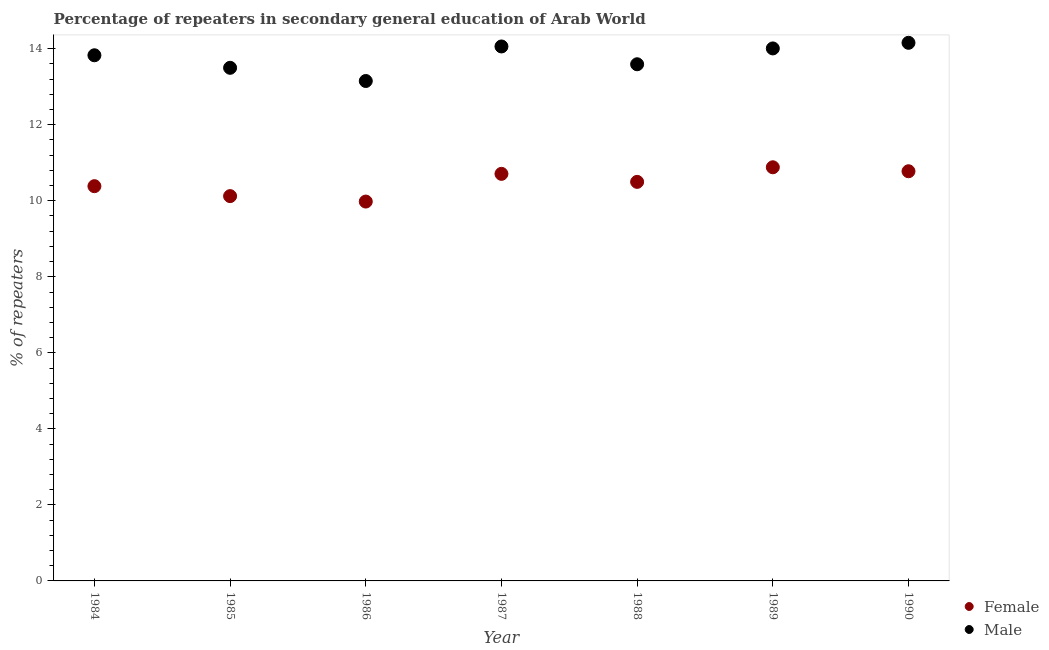How many different coloured dotlines are there?
Provide a succinct answer. 2. Is the number of dotlines equal to the number of legend labels?
Your response must be concise. Yes. What is the percentage of male repeaters in 1986?
Provide a succinct answer. 13.15. Across all years, what is the maximum percentage of female repeaters?
Offer a very short reply. 10.88. Across all years, what is the minimum percentage of female repeaters?
Ensure brevity in your answer.  9.98. In which year was the percentage of male repeaters maximum?
Provide a short and direct response. 1990. What is the total percentage of female repeaters in the graph?
Provide a short and direct response. 73.35. What is the difference between the percentage of male repeaters in 1984 and that in 1990?
Make the answer very short. -0.33. What is the difference between the percentage of male repeaters in 1987 and the percentage of female repeaters in 1988?
Provide a short and direct response. 3.56. What is the average percentage of female repeaters per year?
Provide a succinct answer. 10.48. In the year 1986, what is the difference between the percentage of male repeaters and percentage of female repeaters?
Ensure brevity in your answer.  3.17. In how many years, is the percentage of male repeaters greater than 4 %?
Provide a succinct answer. 7. What is the ratio of the percentage of male repeaters in 1985 to that in 1988?
Provide a short and direct response. 0.99. What is the difference between the highest and the second highest percentage of male repeaters?
Your response must be concise. 0.1. What is the difference between the highest and the lowest percentage of male repeaters?
Offer a terse response. 1. In how many years, is the percentage of female repeaters greater than the average percentage of female repeaters taken over all years?
Provide a succinct answer. 4. Does the percentage of female repeaters monotonically increase over the years?
Provide a short and direct response. No. How many dotlines are there?
Provide a short and direct response. 2. Are the values on the major ticks of Y-axis written in scientific E-notation?
Ensure brevity in your answer.  No. Does the graph contain grids?
Ensure brevity in your answer.  No. Where does the legend appear in the graph?
Your answer should be very brief. Bottom right. How are the legend labels stacked?
Provide a short and direct response. Vertical. What is the title of the graph?
Your answer should be compact. Percentage of repeaters in secondary general education of Arab World. What is the label or title of the Y-axis?
Your answer should be very brief. % of repeaters. What is the % of repeaters in Female in 1984?
Your answer should be very brief. 10.38. What is the % of repeaters of Male in 1984?
Provide a succinct answer. 13.83. What is the % of repeaters of Female in 1985?
Your response must be concise. 10.12. What is the % of repeaters in Male in 1985?
Keep it short and to the point. 13.5. What is the % of repeaters in Female in 1986?
Give a very brief answer. 9.98. What is the % of repeaters in Male in 1986?
Provide a succinct answer. 13.15. What is the % of repeaters of Female in 1987?
Ensure brevity in your answer.  10.71. What is the % of repeaters in Male in 1987?
Your answer should be very brief. 14.06. What is the % of repeaters of Female in 1988?
Provide a short and direct response. 10.5. What is the % of repeaters in Male in 1988?
Provide a succinct answer. 13.59. What is the % of repeaters of Female in 1989?
Your answer should be very brief. 10.88. What is the % of repeaters in Male in 1989?
Your response must be concise. 14.01. What is the % of repeaters in Female in 1990?
Keep it short and to the point. 10.78. What is the % of repeaters in Male in 1990?
Your response must be concise. 14.16. Across all years, what is the maximum % of repeaters of Female?
Your answer should be very brief. 10.88. Across all years, what is the maximum % of repeaters of Male?
Offer a terse response. 14.16. Across all years, what is the minimum % of repeaters of Female?
Your answer should be compact. 9.98. Across all years, what is the minimum % of repeaters in Male?
Provide a succinct answer. 13.15. What is the total % of repeaters in Female in the graph?
Ensure brevity in your answer.  73.35. What is the total % of repeaters of Male in the graph?
Make the answer very short. 96.29. What is the difference between the % of repeaters in Female in 1984 and that in 1985?
Provide a succinct answer. 0.26. What is the difference between the % of repeaters of Male in 1984 and that in 1985?
Keep it short and to the point. 0.33. What is the difference between the % of repeaters in Female in 1984 and that in 1986?
Keep it short and to the point. 0.4. What is the difference between the % of repeaters in Male in 1984 and that in 1986?
Offer a very short reply. 0.68. What is the difference between the % of repeaters of Female in 1984 and that in 1987?
Provide a short and direct response. -0.32. What is the difference between the % of repeaters in Male in 1984 and that in 1987?
Keep it short and to the point. -0.23. What is the difference between the % of repeaters in Female in 1984 and that in 1988?
Offer a terse response. -0.11. What is the difference between the % of repeaters in Male in 1984 and that in 1988?
Make the answer very short. 0.24. What is the difference between the % of repeaters of Female in 1984 and that in 1989?
Your answer should be very brief. -0.5. What is the difference between the % of repeaters in Male in 1984 and that in 1989?
Make the answer very short. -0.18. What is the difference between the % of repeaters of Female in 1984 and that in 1990?
Offer a very short reply. -0.39. What is the difference between the % of repeaters of Male in 1984 and that in 1990?
Offer a very short reply. -0.33. What is the difference between the % of repeaters of Female in 1985 and that in 1986?
Provide a short and direct response. 0.14. What is the difference between the % of repeaters of Male in 1985 and that in 1986?
Provide a succinct answer. 0.35. What is the difference between the % of repeaters in Female in 1985 and that in 1987?
Your answer should be compact. -0.59. What is the difference between the % of repeaters of Male in 1985 and that in 1987?
Provide a short and direct response. -0.56. What is the difference between the % of repeaters of Female in 1985 and that in 1988?
Give a very brief answer. -0.37. What is the difference between the % of repeaters in Male in 1985 and that in 1988?
Ensure brevity in your answer.  -0.09. What is the difference between the % of repeaters in Female in 1985 and that in 1989?
Your answer should be very brief. -0.76. What is the difference between the % of repeaters of Male in 1985 and that in 1989?
Provide a succinct answer. -0.51. What is the difference between the % of repeaters of Female in 1985 and that in 1990?
Give a very brief answer. -0.65. What is the difference between the % of repeaters in Male in 1985 and that in 1990?
Give a very brief answer. -0.66. What is the difference between the % of repeaters in Female in 1986 and that in 1987?
Your answer should be compact. -0.73. What is the difference between the % of repeaters of Male in 1986 and that in 1987?
Give a very brief answer. -0.91. What is the difference between the % of repeaters in Female in 1986 and that in 1988?
Provide a short and direct response. -0.52. What is the difference between the % of repeaters in Male in 1986 and that in 1988?
Provide a short and direct response. -0.44. What is the difference between the % of repeaters in Female in 1986 and that in 1989?
Your answer should be very brief. -0.9. What is the difference between the % of repeaters in Male in 1986 and that in 1989?
Offer a terse response. -0.86. What is the difference between the % of repeaters of Female in 1986 and that in 1990?
Provide a succinct answer. -0.8. What is the difference between the % of repeaters of Male in 1986 and that in 1990?
Keep it short and to the point. -1. What is the difference between the % of repeaters of Female in 1987 and that in 1988?
Keep it short and to the point. 0.21. What is the difference between the % of repeaters of Male in 1987 and that in 1988?
Keep it short and to the point. 0.47. What is the difference between the % of repeaters in Female in 1987 and that in 1989?
Offer a terse response. -0.17. What is the difference between the % of repeaters in Male in 1987 and that in 1989?
Provide a succinct answer. 0.05. What is the difference between the % of repeaters in Female in 1987 and that in 1990?
Make the answer very short. -0.07. What is the difference between the % of repeaters in Male in 1987 and that in 1990?
Provide a short and direct response. -0.1. What is the difference between the % of repeaters of Female in 1988 and that in 1989?
Make the answer very short. -0.38. What is the difference between the % of repeaters of Male in 1988 and that in 1989?
Keep it short and to the point. -0.42. What is the difference between the % of repeaters of Female in 1988 and that in 1990?
Give a very brief answer. -0.28. What is the difference between the % of repeaters in Male in 1988 and that in 1990?
Your response must be concise. -0.56. What is the difference between the % of repeaters in Female in 1989 and that in 1990?
Your answer should be compact. 0.1. What is the difference between the % of repeaters in Male in 1989 and that in 1990?
Give a very brief answer. -0.15. What is the difference between the % of repeaters of Female in 1984 and the % of repeaters of Male in 1985?
Your response must be concise. -3.11. What is the difference between the % of repeaters of Female in 1984 and the % of repeaters of Male in 1986?
Your answer should be very brief. -2.77. What is the difference between the % of repeaters in Female in 1984 and the % of repeaters in Male in 1987?
Offer a terse response. -3.68. What is the difference between the % of repeaters in Female in 1984 and the % of repeaters in Male in 1988?
Give a very brief answer. -3.21. What is the difference between the % of repeaters of Female in 1984 and the % of repeaters of Male in 1989?
Offer a terse response. -3.62. What is the difference between the % of repeaters in Female in 1984 and the % of repeaters in Male in 1990?
Ensure brevity in your answer.  -3.77. What is the difference between the % of repeaters in Female in 1985 and the % of repeaters in Male in 1986?
Provide a succinct answer. -3.03. What is the difference between the % of repeaters of Female in 1985 and the % of repeaters of Male in 1987?
Offer a very short reply. -3.94. What is the difference between the % of repeaters in Female in 1985 and the % of repeaters in Male in 1988?
Offer a very short reply. -3.47. What is the difference between the % of repeaters in Female in 1985 and the % of repeaters in Male in 1989?
Offer a very short reply. -3.89. What is the difference between the % of repeaters in Female in 1985 and the % of repeaters in Male in 1990?
Make the answer very short. -4.03. What is the difference between the % of repeaters of Female in 1986 and the % of repeaters of Male in 1987?
Provide a short and direct response. -4.08. What is the difference between the % of repeaters in Female in 1986 and the % of repeaters in Male in 1988?
Ensure brevity in your answer.  -3.61. What is the difference between the % of repeaters in Female in 1986 and the % of repeaters in Male in 1989?
Your response must be concise. -4.03. What is the difference between the % of repeaters in Female in 1986 and the % of repeaters in Male in 1990?
Your answer should be very brief. -4.18. What is the difference between the % of repeaters of Female in 1987 and the % of repeaters of Male in 1988?
Your answer should be compact. -2.88. What is the difference between the % of repeaters in Female in 1987 and the % of repeaters in Male in 1989?
Give a very brief answer. -3.3. What is the difference between the % of repeaters of Female in 1987 and the % of repeaters of Male in 1990?
Keep it short and to the point. -3.45. What is the difference between the % of repeaters of Female in 1988 and the % of repeaters of Male in 1989?
Ensure brevity in your answer.  -3.51. What is the difference between the % of repeaters of Female in 1988 and the % of repeaters of Male in 1990?
Offer a very short reply. -3.66. What is the difference between the % of repeaters of Female in 1989 and the % of repeaters of Male in 1990?
Make the answer very short. -3.27. What is the average % of repeaters of Female per year?
Provide a succinct answer. 10.48. What is the average % of repeaters of Male per year?
Offer a very short reply. 13.76. In the year 1984, what is the difference between the % of repeaters in Female and % of repeaters in Male?
Give a very brief answer. -3.44. In the year 1985, what is the difference between the % of repeaters of Female and % of repeaters of Male?
Give a very brief answer. -3.38. In the year 1986, what is the difference between the % of repeaters of Female and % of repeaters of Male?
Your response must be concise. -3.17. In the year 1987, what is the difference between the % of repeaters in Female and % of repeaters in Male?
Ensure brevity in your answer.  -3.35. In the year 1988, what is the difference between the % of repeaters in Female and % of repeaters in Male?
Your response must be concise. -3.09. In the year 1989, what is the difference between the % of repeaters of Female and % of repeaters of Male?
Offer a very short reply. -3.13. In the year 1990, what is the difference between the % of repeaters of Female and % of repeaters of Male?
Your response must be concise. -3.38. What is the ratio of the % of repeaters in Female in 1984 to that in 1985?
Offer a terse response. 1.03. What is the ratio of the % of repeaters of Male in 1984 to that in 1985?
Offer a terse response. 1.02. What is the ratio of the % of repeaters of Female in 1984 to that in 1986?
Provide a succinct answer. 1.04. What is the ratio of the % of repeaters in Male in 1984 to that in 1986?
Ensure brevity in your answer.  1.05. What is the ratio of the % of repeaters of Female in 1984 to that in 1987?
Your response must be concise. 0.97. What is the ratio of the % of repeaters of Male in 1984 to that in 1987?
Provide a succinct answer. 0.98. What is the ratio of the % of repeaters of Female in 1984 to that in 1988?
Make the answer very short. 0.99. What is the ratio of the % of repeaters of Male in 1984 to that in 1988?
Make the answer very short. 1.02. What is the ratio of the % of repeaters in Female in 1984 to that in 1989?
Ensure brevity in your answer.  0.95. What is the ratio of the % of repeaters of Male in 1984 to that in 1989?
Make the answer very short. 0.99. What is the ratio of the % of repeaters of Female in 1984 to that in 1990?
Your answer should be very brief. 0.96. What is the ratio of the % of repeaters of Male in 1984 to that in 1990?
Give a very brief answer. 0.98. What is the ratio of the % of repeaters in Female in 1985 to that in 1986?
Keep it short and to the point. 1.01. What is the ratio of the % of repeaters of Male in 1985 to that in 1986?
Offer a terse response. 1.03. What is the ratio of the % of repeaters in Female in 1985 to that in 1987?
Your answer should be compact. 0.95. What is the ratio of the % of repeaters of Male in 1985 to that in 1987?
Provide a succinct answer. 0.96. What is the ratio of the % of repeaters of Female in 1985 to that in 1989?
Provide a short and direct response. 0.93. What is the ratio of the % of repeaters in Male in 1985 to that in 1989?
Give a very brief answer. 0.96. What is the ratio of the % of repeaters of Female in 1985 to that in 1990?
Offer a very short reply. 0.94. What is the ratio of the % of repeaters in Male in 1985 to that in 1990?
Give a very brief answer. 0.95. What is the ratio of the % of repeaters of Female in 1986 to that in 1987?
Make the answer very short. 0.93. What is the ratio of the % of repeaters of Male in 1986 to that in 1987?
Your answer should be very brief. 0.94. What is the ratio of the % of repeaters of Female in 1986 to that in 1988?
Offer a terse response. 0.95. What is the ratio of the % of repeaters in Male in 1986 to that in 1988?
Provide a succinct answer. 0.97. What is the ratio of the % of repeaters in Female in 1986 to that in 1989?
Offer a terse response. 0.92. What is the ratio of the % of repeaters in Male in 1986 to that in 1989?
Provide a short and direct response. 0.94. What is the ratio of the % of repeaters in Female in 1986 to that in 1990?
Offer a terse response. 0.93. What is the ratio of the % of repeaters in Male in 1986 to that in 1990?
Your answer should be very brief. 0.93. What is the ratio of the % of repeaters in Female in 1987 to that in 1988?
Your answer should be compact. 1.02. What is the ratio of the % of repeaters in Male in 1987 to that in 1988?
Your answer should be very brief. 1.03. What is the ratio of the % of repeaters in Female in 1987 to that in 1989?
Offer a very short reply. 0.98. What is the ratio of the % of repeaters in Male in 1987 to that in 1989?
Offer a very short reply. 1. What is the ratio of the % of repeaters of Female in 1987 to that in 1990?
Keep it short and to the point. 0.99. What is the ratio of the % of repeaters of Female in 1988 to that in 1989?
Provide a succinct answer. 0.96. What is the ratio of the % of repeaters in Male in 1988 to that in 1989?
Offer a terse response. 0.97. What is the ratio of the % of repeaters of Female in 1988 to that in 1990?
Offer a terse response. 0.97. What is the ratio of the % of repeaters of Male in 1988 to that in 1990?
Your answer should be compact. 0.96. What is the ratio of the % of repeaters in Female in 1989 to that in 1990?
Provide a short and direct response. 1.01. What is the difference between the highest and the second highest % of repeaters in Female?
Your answer should be very brief. 0.1. What is the difference between the highest and the second highest % of repeaters of Male?
Give a very brief answer. 0.1. What is the difference between the highest and the lowest % of repeaters of Female?
Offer a terse response. 0.9. 